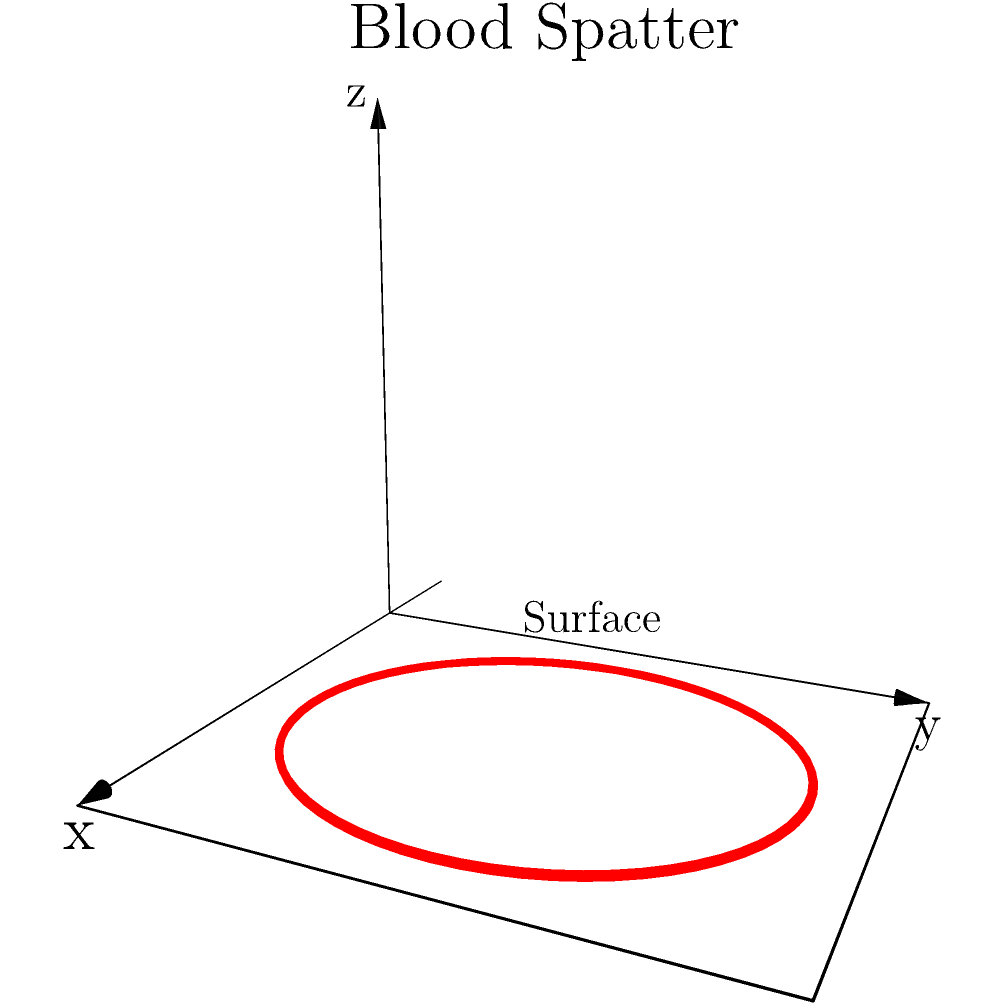A blood spatter pattern on a flat surface has been determined to have an irregular, roughly circular shape. The diameter of the spatter varies between 15 cm and 17 cm, with an average thickness of 0.2 mm. Estimate the volume of blood in this spatter pattern, assuming it can be approximated as a cylindrical shape. Round your answer to the nearest mL. To estimate the volume of the blood spatter, we'll use the formula for the volume of a cylinder:

$$V = \pi r^2 h$$

Where:
- $V$ is the volume
- $r$ is the radius of the base
- $h$ is the height (thickness) of the cylinder

Step 1: Determine the average radius
The diameter varies between 15 cm and 17 cm. We'll use the average:
$$\text{Average diameter} = \frac{15 \text{ cm} + 17 \text{ cm}}{2} = 16 \text{ cm}$$
$$\text{Radius} = \frac{16 \text{ cm}}{2} = 8 \text{ cm} = 0.08 \text{ m}$$

Step 2: Convert the thickness to meters
$$0.2 \text{ mm} = 0.0002 \text{ m}$$

Step 3: Calculate the volume
$$\begin{align*}
V &= \pi r^2 h \\
&= \pi (0.08 \text{ m})^2 (0.0002 \text{ m}) \\
&= \pi (0.0064 \text{ m}^2) (0.0002 \text{ m}) \\
&= 0.00000040106 \pi \text{ m}^3 \\
&\approx 0.00000125664 \text{ m}^3
\end{align*}$$

Step 4: Convert to milliliters
$$0.00000125664 \text{ m}^3 \times 1,000,000 \text{ mL/m}^3 = 1.25664 \text{ mL}$$

Step 5: Round to the nearest mL
$$1.25664 \text{ mL} \approx 1 \text{ mL}$$
Answer: 1 mL 